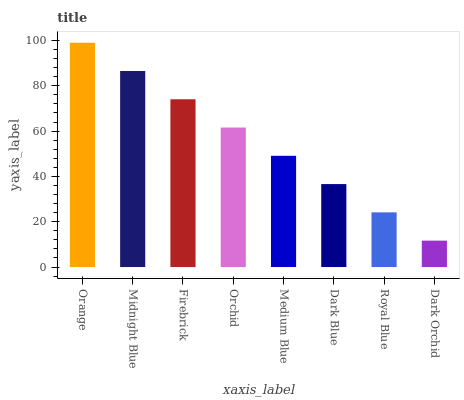Is Dark Orchid the minimum?
Answer yes or no. Yes. Is Orange the maximum?
Answer yes or no. Yes. Is Midnight Blue the minimum?
Answer yes or no. No. Is Midnight Blue the maximum?
Answer yes or no. No. Is Orange greater than Midnight Blue?
Answer yes or no. Yes. Is Midnight Blue less than Orange?
Answer yes or no. Yes. Is Midnight Blue greater than Orange?
Answer yes or no. No. Is Orange less than Midnight Blue?
Answer yes or no. No. Is Orchid the high median?
Answer yes or no. Yes. Is Medium Blue the low median?
Answer yes or no. Yes. Is Royal Blue the high median?
Answer yes or no. No. Is Orange the low median?
Answer yes or no. No. 